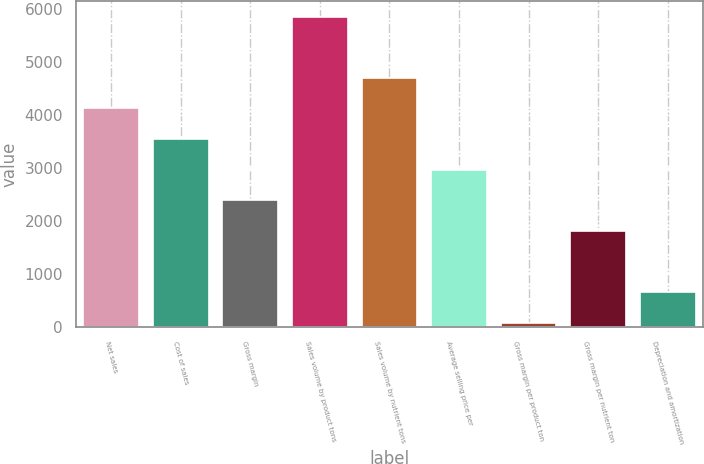Convert chart. <chart><loc_0><loc_0><loc_500><loc_500><bar_chart><fcel>Net sales<fcel>Cost of sales<fcel>Gross margin<fcel>Sales volume by product tons<fcel>Sales volume by nutrient tons<fcel>Average selling price per<fcel>Gross margin per product ton<fcel>Gross margin per nutrient ton<fcel>Depreciation and amortization<nl><fcel>4132.5<fcel>3555<fcel>2400<fcel>5865<fcel>4710<fcel>2977.5<fcel>90<fcel>1822.5<fcel>667.5<nl></chart> 